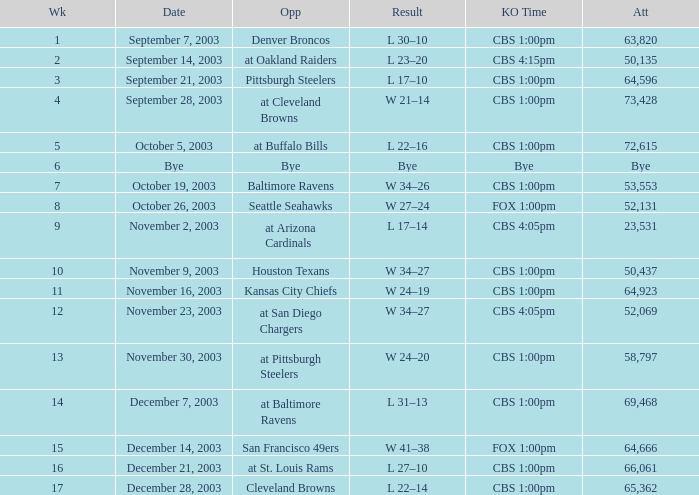What was the kickoff time on week 1? CBS 1:00pm. 